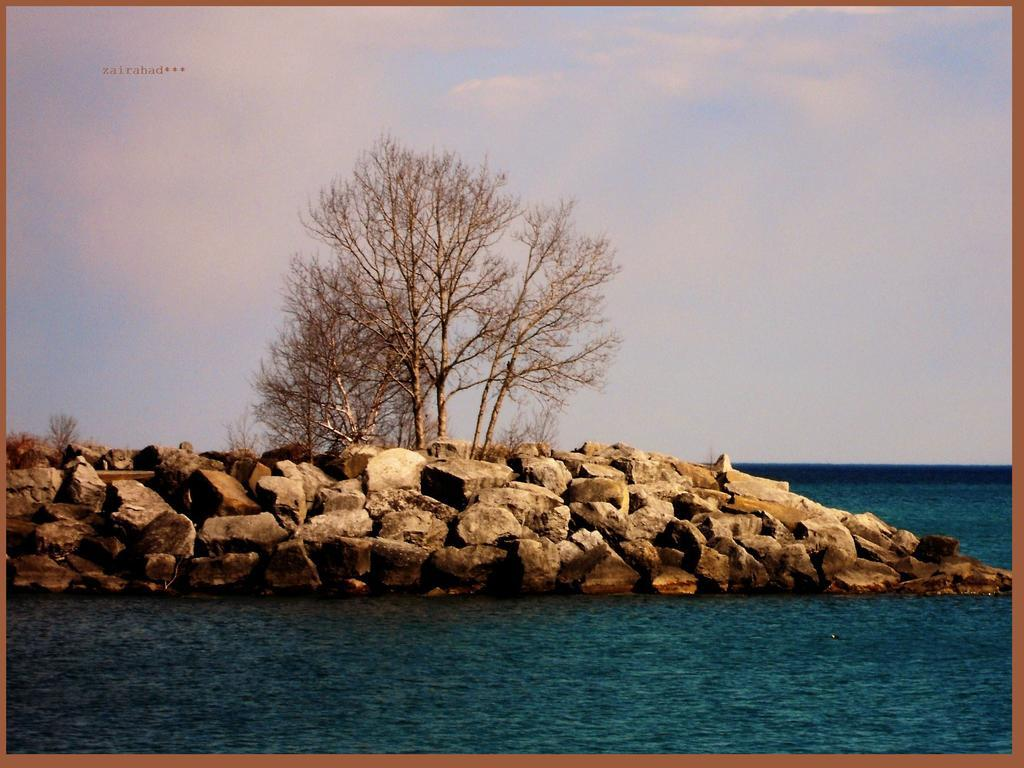What type of natural elements can be seen in the image? There are rocks and dried trees visible in the image. What else can be seen in the image besides the rocks and dried trees? There is water visible in the image. What is visible in the background of the image? The sky is visible in the background of the image. What can be observed in the sky? There are clouds in the sky. Can you see a fan in the image? There is no fan present in the image. Are there any ghosts visible in the image? There are no ghosts present in the image. 